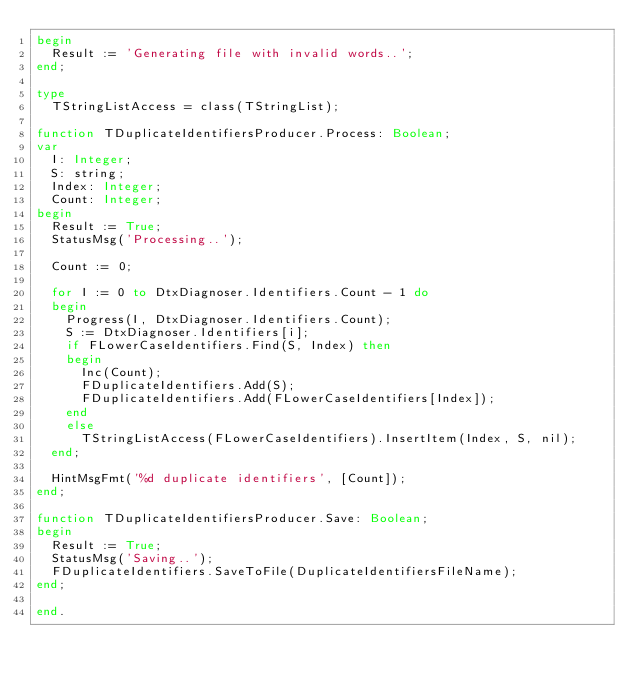<code> <loc_0><loc_0><loc_500><loc_500><_Pascal_>begin
  Result := 'Generating file with invalid words..';
end;

type
  TStringListAccess = class(TStringList);

function TDuplicateIdentifiersProducer.Process: Boolean;
var
  I: Integer;
  S: string;
  Index: Integer;
  Count: Integer;
begin
  Result := True;
  StatusMsg('Processing..');

  Count := 0;

  for I := 0 to DtxDiagnoser.Identifiers.Count - 1 do
  begin
    Progress(I, DtxDiagnoser.Identifiers.Count);
    S := DtxDiagnoser.Identifiers[i];
    if FLowerCaseIdentifiers.Find(S, Index) then
    begin
      Inc(Count);
      FDuplicateIdentifiers.Add(S);
      FDuplicateIdentifiers.Add(FLowerCaseIdentifiers[Index]);
    end
    else
      TStringListAccess(FLowerCaseIdentifiers).InsertItem(Index, S, nil);
  end;

  HintMsgFmt('%d duplicate identifiers', [Count]);
end;

function TDuplicateIdentifiersProducer.Save: Boolean;
begin
  Result := True;
  StatusMsg('Saving..');
  FDuplicateIdentifiers.SaveToFile(DuplicateIdentifiersFileName);
end;

end.

 </code> 